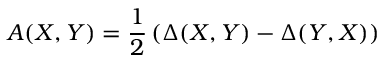<formula> <loc_0><loc_0><loc_500><loc_500>A ( X , Y ) = { \frac { 1 } { 2 } } \left ( \Delta ( X , Y ) - \Delta ( Y , X ) \right )</formula> 